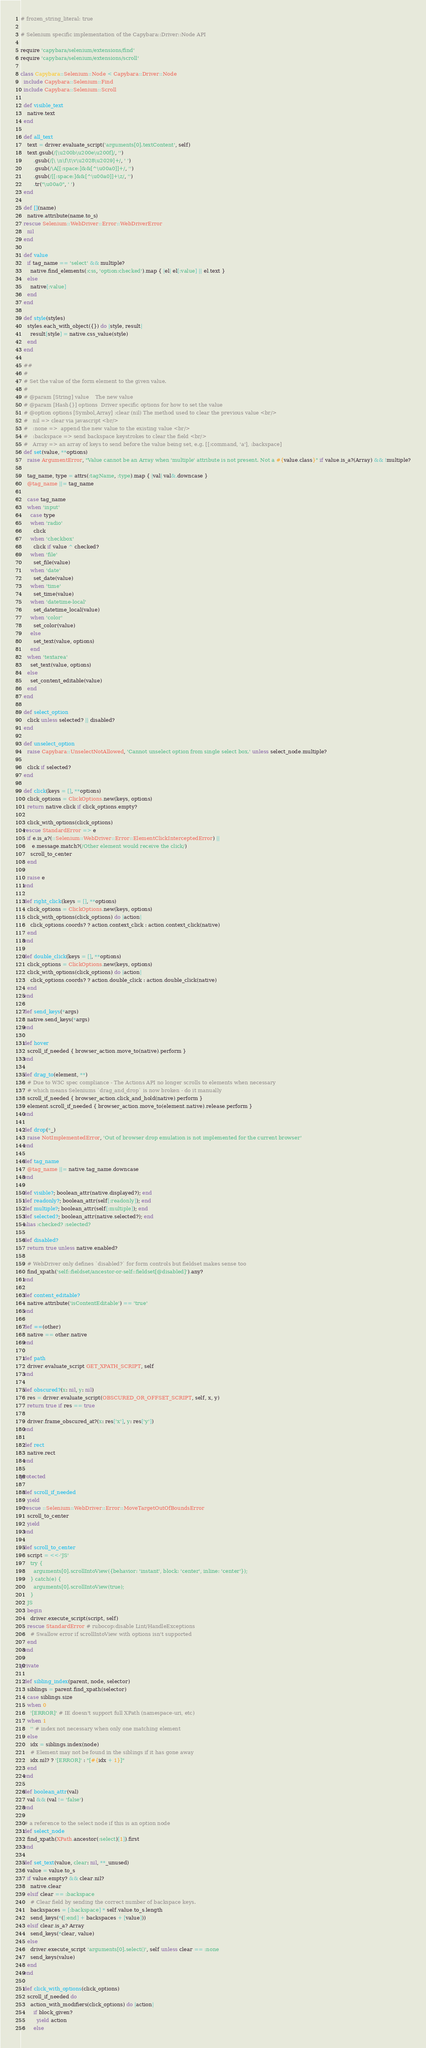Convert code to text. <code><loc_0><loc_0><loc_500><loc_500><_Ruby_># frozen_string_literal: true

# Selenium specific implementation of the Capybara::Driver::Node API

require 'capybara/selenium/extensions/find'
require 'capybara/selenium/extensions/scroll'

class Capybara::Selenium::Node < Capybara::Driver::Node
  include Capybara::Selenium::Find
  include Capybara::Selenium::Scroll

  def visible_text
    native.text
  end

  def all_text
    text = driver.evaluate_script('arguments[0].textContent', self)
    text.gsub(/[\u200b\u200e\u200f]/, '')
        .gsub(/[\ \n\f\t\v\u2028\u2029]+/, ' ')
        .gsub(/\A[[:space:]&&[^\u00a0]]+/, '')
        .gsub(/[[:space:]&&[^\u00a0]]+\z/, '')
        .tr("\u00a0", ' ')
  end

  def [](name)
    native.attribute(name.to_s)
  rescue Selenium::WebDriver::Error::WebDriverError
    nil
  end

  def value
    if tag_name == 'select' && multiple?
      native.find_elements(:css, 'option:checked').map { |el| el[:value] || el.text }
    else
      native[:value]
    end
  end

  def style(styles)
    styles.each_with_object({}) do |style, result|
      result[style] = native.css_value(style)
    end
  end

  ##
  #
  # Set the value of the form element to the given value.
  #
  # @param [String] value    The new value
  # @param [Hash{}] options  Driver specific options for how to set the value
  # @option options [Symbol,Array] :clear (nil) The method used to clear the previous value <br/>
  #   nil => clear via javascript <br/>
  #   :none =>  append the new value to the existing value <br/>
  #   :backspace => send backspace keystrokes to clear the field <br/>
  #   Array => an array of keys to send before the value being set, e.g. [[:command, 'a'], :backspace]
  def set(value, **options)
    raise ArgumentError, "Value cannot be an Array when 'multiple' attribute is not present. Not a #{value.class}" if value.is_a?(Array) && !multiple?

    tag_name, type = attrs(:tagName, :type).map { |val| val&.downcase }
    @tag_name ||= tag_name

    case tag_name
    when 'input'
      case type
      when 'radio'
        click
      when 'checkbox'
        click if value ^ checked?
      when 'file'
        set_file(value)
      when 'date'
        set_date(value)
      when 'time'
        set_time(value)
      when 'datetime-local'
        set_datetime_local(value)
      when 'color'
        set_color(value)
      else
        set_text(value, options)
      end
    when 'textarea'
      set_text(value, options)
    else
      set_content_editable(value)
    end
  end

  def select_option
    click unless selected? || disabled?
  end

  def unselect_option
    raise Capybara::UnselectNotAllowed, 'Cannot unselect option from single select box.' unless select_node.multiple?

    click if selected?
  end

  def click(keys = [], **options)
    click_options = ClickOptions.new(keys, options)
    return native.click if click_options.empty?

    click_with_options(click_options)
  rescue StandardError => e
    if e.is_a?(::Selenium::WebDriver::Error::ElementClickInterceptedError) ||
       e.message.match?(/Other element would receive the click/)
      scroll_to_center
    end

    raise e
  end

  def right_click(keys = [], **options)
    click_options = ClickOptions.new(keys, options)
    click_with_options(click_options) do |action|
      click_options.coords? ? action.context_click : action.context_click(native)
    end
  end

  def double_click(keys = [], **options)
    click_options = ClickOptions.new(keys, options)
    click_with_options(click_options) do |action|
      click_options.coords? ? action.double_click : action.double_click(native)
    end
  end

  def send_keys(*args)
    native.send_keys(*args)
  end

  def hover
    scroll_if_needed { browser_action.move_to(native).perform }
  end

  def drag_to(element, **)
    # Due to W3C spec compliance - The Actions API no longer scrolls to elements when necessary
    # which means Seleniums `drag_and_drop` is now broken - do it manually
    scroll_if_needed { browser_action.click_and_hold(native).perform }
    element.scroll_if_needed { browser_action.move_to(element.native).release.perform }
  end

  def drop(*_)
    raise NotImplementedError, 'Out of browser drop emulation is not implemented for the current browser'
  end

  def tag_name
    @tag_name ||= native.tag_name.downcase
  end

  def visible?; boolean_attr(native.displayed?); end
  def readonly?; boolean_attr(self[:readonly]); end
  def multiple?; boolean_attr(self[:multiple]); end
  def selected?; boolean_attr(native.selected?); end
  alias :checked? :selected?

  def disabled?
    return true unless native.enabled?

    # WebDriver only defines `disabled?` for form controls but fieldset makes sense too
    find_xpath('self::fieldset/ancestor-or-self::fieldset[@disabled]').any?
  end

  def content_editable?
    native.attribute('isContentEditable') == 'true'
  end

  def ==(other)
    native == other.native
  end

  def path
    driver.evaluate_script GET_XPATH_SCRIPT, self
  end

  def obscured?(x: nil, y: nil)
    res = driver.evaluate_script(OBSCURED_OR_OFFSET_SCRIPT, self, x, y)
    return true if res == true

    driver.frame_obscured_at?(x: res['x'], y: res['y'])
  end

  def rect
    native.rect
  end

protected

  def scroll_if_needed
    yield
  rescue ::Selenium::WebDriver::Error::MoveTargetOutOfBoundsError
    scroll_to_center
    yield
  end

  def scroll_to_center
    script = <<-'JS'
      try {
        arguments[0].scrollIntoView({behavior: 'instant', block: 'center', inline: 'center'});
      } catch(e) {
        arguments[0].scrollIntoView(true);
      }
    JS
    begin
      driver.execute_script(script, self)
    rescue StandardError # rubocop:disable Lint/HandleExceptions
      # Swallow error if scrollIntoView with options isn't supported
    end
  end

private

  def sibling_index(parent, node, selector)
    siblings = parent.find_xpath(selector)
    case siblings.size
    when 0
      '[ERROR]' # IE doesn't support full XPath (namespace-uri, etc)
    when 1
      '' # index not necessary when only one matching element
    else
      idx = siblings.index(node)
      # Element may not be found in the siblings if it has gone away
      idx.nil? ? '[ERROR]' : "[#{idx + 1}]"
    end
  end

  def boolean_attr(val)
    val && (val != 'false')
  end

  # a reference to the select node if this is an option node
  def select_node
    find_xpath(XPath.ancestor(:select)[1]).first
  end

  def set_text(value, clear: nil, **_unused)
    value = value.to_s
    if value.empty? && clear.nil?
      native.clear
    elsif clear == :backspace
      # Clear field by sending the correct number of backspace keys.
      backspaces = [:backspace] * self.value.to_s.length
      send_keys(*([:end] + backspaces + [value]))
    elsif clear.is_a? Array
      send_keys(*clear, value)
    else
      driver.execute_script 'arguments[0].select()', self unless clear == :none
      send_keys(value)
    end
  end

  def click_with_options(click_options)
    scroll_if_needed do
      action_with_modifiers(click_options) do |action|
        if block_given?
          yield action
        else</code> 